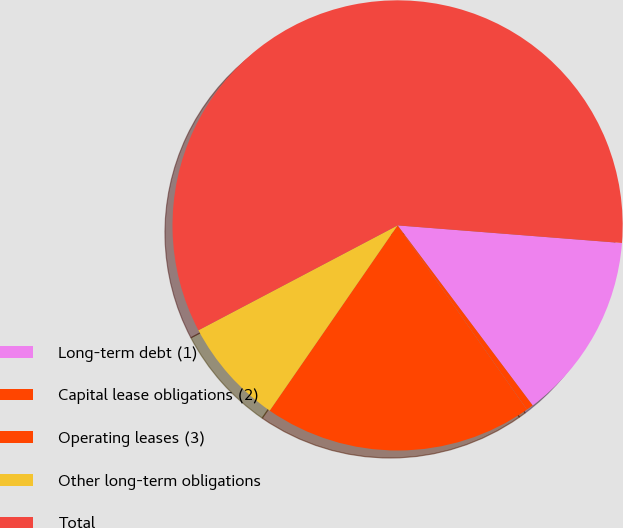Convert chart. <chart><loc_0><loc_0><loc_500><loc_500><pie_chart><fcel>Long-term debt (1)<fcel>Capital lease obligations (2)<fcel>Operating leases (3)<fcel>Other long-term obligations<fcel>Total<nl><fcel>13.51%<fcel>0.5%<fcel>19.36%<fcel>7.67%<fcel>58.96%<nl></chart> 